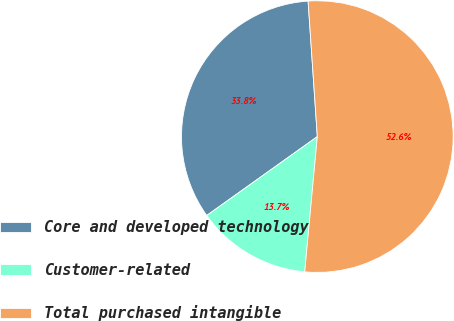<chart> <loc_0><loc_0><loc_500><loc_500><pie_chart><fcel>Core and developed technology<fcel>Customer-related<fcel>Total purchased intangible<nl><fcel>33.78%<fcel>13.66%<fcel>52.56%<nl></chart> 